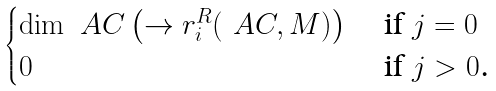<formula> <loc_0><loc_0><loc_500><loc_500>\begin{cases} \dim _ { \ } A C \left ( \to r _ { i } ^ { R } ( \ A C , M ) \right ) & \text { if $j= 0$} \\ 0 & \text { if $j>0$.} \end{cases}</formula> 